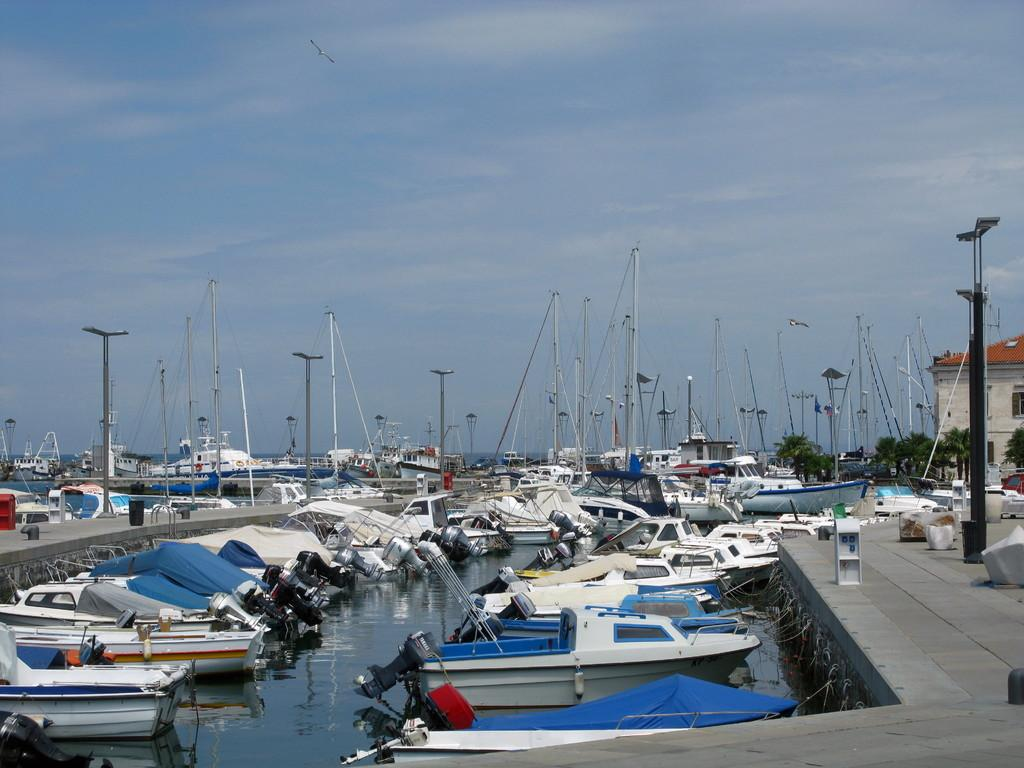What is happening on the water in the image? There are boats on water in the image. What structure can be seen in the image? There is a platform in the image. What objects are present in the image that are used for support or guidance? There are poles in the image. What type of vegetation is visible in the image? There are trees in the image. What type of building is present in the image? There is a house with windows in the image. What can be seen in the background of the image? The sky with clouds is visible in the background of the image. What type of wrench is being used to cook in the image? There is no wrench or cooking activity present in the image. How does the house provide comfort to the people in the image? The image does not show any people or indicate the level of comfort provided by the house. 